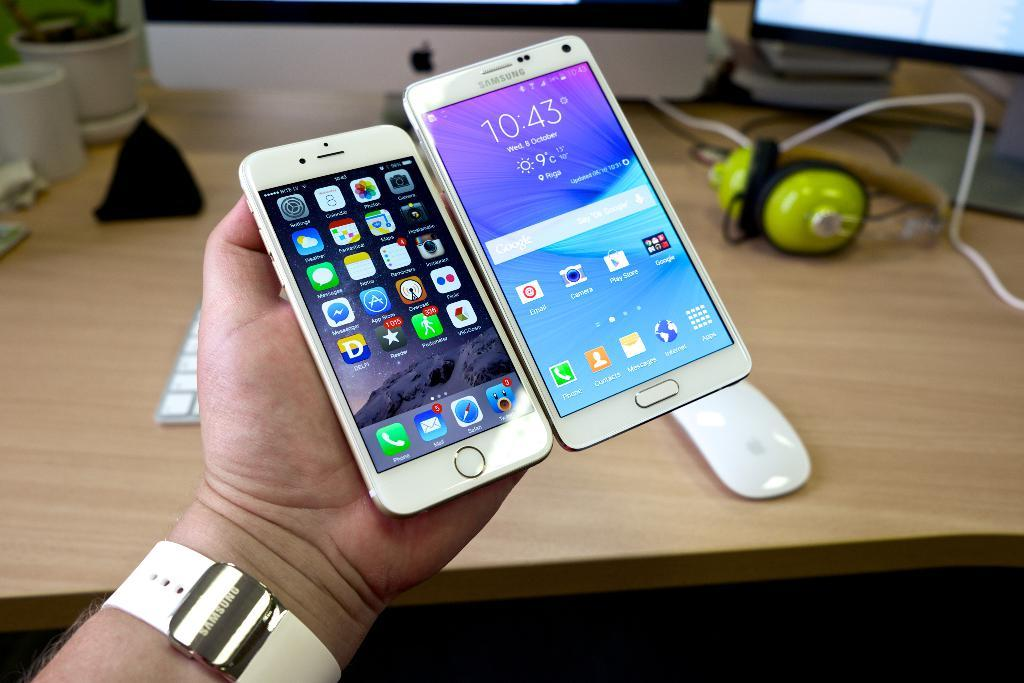What is the person holding in the image? There is a person's hand holding two mobile phones in the image. What type of furniture is in the image? There is a desk in the image. What type of accessories are on the desk? Headsets and a mouse are visible on the desk. What part of a computer setup is visible in the image? A part of the monitor and a keyboard are present on the desk. What type of water feature can be seen in the image? There is no water feature present in the image. How many brothers are visible in the image? There are no brothers present in the image. 